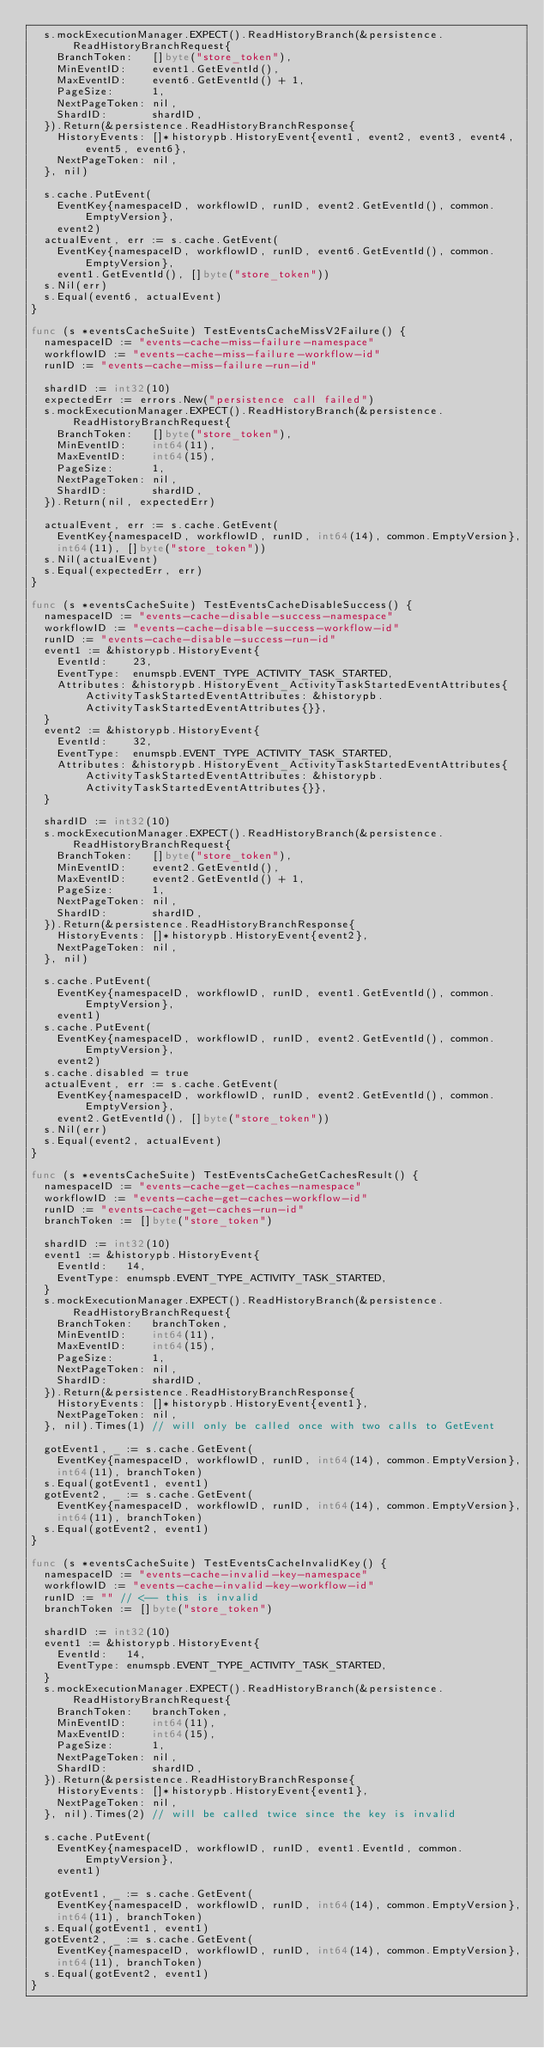<code> <loc_0><loc_0><loc_500><loc_500><_Go_>	s.mockExecutionManager.EXPECT().ReadHistoryBranch(&persistence.ReadHistoryBranchRequest{
		BranchToken:   []byte("store_token"),
		MinEventID:    event1.GetEventId(),
		MaxEventID:    event6.GetEventId() + 1,
		PageSize:      1,
		NextPageToken: nil,
		ShardID:       shardID,
	}).Return(&persistence.ReadHistoryBranchResponse{
		HistoryEvents: []*historypb.HistoryEvent{event1, event2, event3, event4, event5, event6},
		NextPageToken: nil,
	}, nil)

	s.cache.PutEvent(
		EventKey{namespaceID, workflowID, runID, event2.GetEventId(), common.EmptyVersion},
		event2)
	actualEvent, err := s.cache.GetEvent(
		EventKey{namespaceID, workflowID, runID, event6.GetEventId(), common.EmptyVersion},
		event1.GetEventId(), []byte("store_token"))
	s.Nil(err)
	s.Equal(event6, actualEvent)
}

func (s *eventsCacheSuite) TestEventsCacheMissV2Failure() {
	namespaceID := "events-cache-miss-failure-namespace"
	workflowID := "events-cache-miss-failure-workflow-id"
	runID := "events-cache-miss-failure-run-id"

	shardID := int32(10)
	expectedErr := errors.New("persistence call failed")
	s.mockExecutionManager.EXPECT().ReadHistoryBranch(&persistence.ReadHistoryBranchRequest{
		BranchToken:   []byte("store_token"),
		MinEventID:    int64(11),
		MaxEventID:    int64(15),
		PageSize:      1,
		NextPageToken: nil,
		ShardID:       shardID,
	}).Return(nil, expectedErr)

	actualEvent, err := s.cache.GetEvent(
		EventKey{namespaceID, workflowID, runID, int64(14), common.EmptyVersion},
		int64(11), []byte("store_token"))
	s.Nil(actualEvent)
	s.Equal(expectedErr, err)
}

func (s *eventsCacheSuite) TestEventsCacheDisableSuccess() {
	namespaceID := "events-cache-disable-success-namespace"
	workflowID := "events-cache-disable-success-workflow-id"
	runID := "events-cache-disable-success-run-id"
	event1 := &historypb.HistoryEvent{
		EventId:    23,
		EventType:  enumspb.EVENT_TYPE_ACTIVITY_TASK_STARTED,
		Attributes: &historypb.HistoryEvent_ActivityTaskStartedEventAttributes{ActivityTaskStartedEventAttributes: &historypb.ActivityTaskStartedEventAttributes{}},
	}
	event2 := &historypb.HistoryEvent{
		EventId:    32,
		EventType:  enumspb.EVENT_TYPE_ACTIVITY_TASK_STARTED,
		Attributes: &historypb.HistoryEvent_ActivityTaskStartedEventAttributes{ActivityTaskStartedEventAttributes: &historypb.ActivityTaskStartedEventAttributes{}},
	}

	shardID := int32(10)
	s.mockExecutionManager.EXPECT().ReadHistoryBranch(&persistence.ReadHistoryBranchRequest{
		BranchToken:   []byte("store_token"),
		MinEventID:    event2.GetEventId(),
		MaxEventID:    event2.GetEventId() + 1,
		PageSize:      1,
		NextPageToken: nil,
		ShardID:       shardID,
	}).Return(&persistence.ReadHistoryBranchResponse{
		HistoryEvents: []*historypb.HistoryEvent{event2},
		NextPageToken: nil,
	}, nil)

	s.cache.PutEvent(
		EventKey{namespaceID, workflowID, runID, event1.GetEventId(), common.EmptyVersion},
		event1)
	s.cache.PutEvent(
		EventKey{namespaceID, workflowID, runID, event2.GetEventId(), common.EmptyVersion},
		event2)
	s.cache.disabled = true
	actualEvent, err := s.cache.GetEvent(
		EventKey{namespaceID, workflowID, runID, event2.GetEventId(), common.EmptyVersion},
		event2.GetEventId(), []byte("store_token"))
	s.Nil(err)
	s.Equal(event2, actualEvent)
}

func (s *eventsCacheSuite) TestEventsCacheGetCachesResult() {
	namespaceID := "events-cache-get-caches-namespace"
	workflowID := "events-cache-get-caches-workflow-id"
	runID := "events-cache-get-caches-run-id"
	branchToken := []byte("store_token")

	shardID := int32(10)
	event1 := &historypb.HistoryEvent{
		EventId:   14,
		EventType: enumspb.EVENT_TYPE_ACTIVITY_TASK_STARTED,
	}
	s.mockExecutionManager.EXPECT().ReadHistoryBranch(&persistence.ReadHistoryBranchRequest{
		BranchToken:   branchToken,
		MinEventID:    int64(11),
		MaxEventID:    int64(15),
		PageSize:      1,
		NextPageToken: nil,
		ShardID:       shardID,
	}).Return(&persistence.ReadHistoryBranchResponse{
		HistoryEvents: []*historypb.HistoryEvent{event1},
		NextPageToken: nil,
	}, nil).Times(1) // will only be called once with two calls to GetEvent

	gotEvent1, _ := s.cache.GetEvent(
		EventKey{namespaceID, workflowID, runID, int64(14), common.EmptyVersion},
		int64(11), branchToken)
	s.Equal(gotEvent1, event1)
	gotEvent2, _ := s.cache.GetEvent(
		EventKey{namespaceID, workflowID, runID, int64(14), common.EmptyVersion},
		int64(11), branchToken)
	s.Equal(gotEvent2, event1)
}

func (s *eventsCacheSuite) TestEventsCacheInvalidKey() {
	namespaceID := "events-cache-invalid-key-namespace"
	workflowID := "events-cache-invalid-key-workflow-id"
	runID := "" // <-- this is invalid
	branchToken := []byte("store_token")

	shardID := int32(10)
	event1 := &historypb.HistoryEvent{
		EventId:   14,
		EventType: enumspb.EVENT_TYPE_ACTIVITY_TASK_STARTED,
	}
	s.mockExecutionManager.EXPECT().ReadHistoryBranch(&persistence.ReadHistoryBranchRequest{
		BranchToken:   branchToken,
		MinEventID:    int64(11),
		MaxEventID:    int64(15),
		PageSize:      1,
		NextPageToken: nil,
		ShardID:       shardID,
	}).Return(&persistence.ReadHistoryBranchResponse{
		HistoryEvents: []*historypb.HistoryEvent{event1},
		NextPageToken: nil,
	}, nil).Times(2) // will be called twice since the key is invalid

	s.cache.PutEvent(
		EventKey{namespaceID, workflowID, runID, event1.EventId, common.EmptyVersion},
		event1)

	gotEvent1, _ := s.cache.GetEvent(
		EventKey{namespaceID, workflowID, runID, int64(14), common.EmptyVersion},
		int64(11), branchToken)
	s.Equal(gotEvent1, event1)
	gotEvent2, _ := s.cache.GetEvent(
		EventKey{namespaceID, workflowID, runID, int64(14), common.EmptyVersion},
		int64(11), branchToken)
	s.Equal(gotEvent2, event1)
}
</code> 